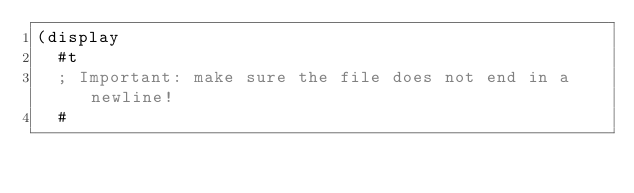Convert code to text. <code><loc_0><loc_0><loc_500><loc_500><_Scheme_>(display
  #t
  ; Important: make sure the file does not end in a newline!
  #</code> 